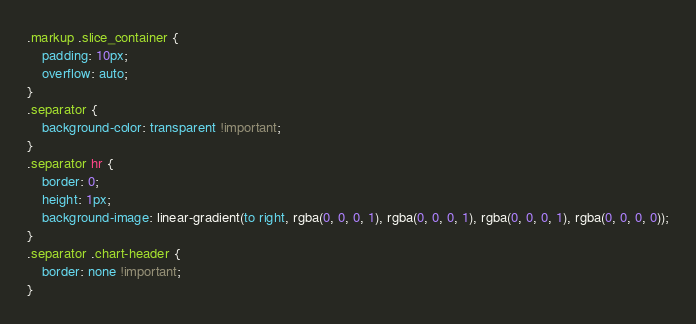Convert code to text. <code><loc_0><loc_0><loc_500><loc_500><_CSS_>.markup .slice_container {
    padding: 10px;
    overflow: auto;
}
.separator {
    background-color: transparent !important;
}
.separator hr {
    border: 0;
    height: 1px;
    background-image: linear-gradient(to right, rgba(0, 0, 0, 1), rgba(0, 0, 0, 1), rgba(0, 0, 0, 1), rgba(0, 0, 0, 0));
}
.separator .chart-header {
    border: none !important;
}
</code> 